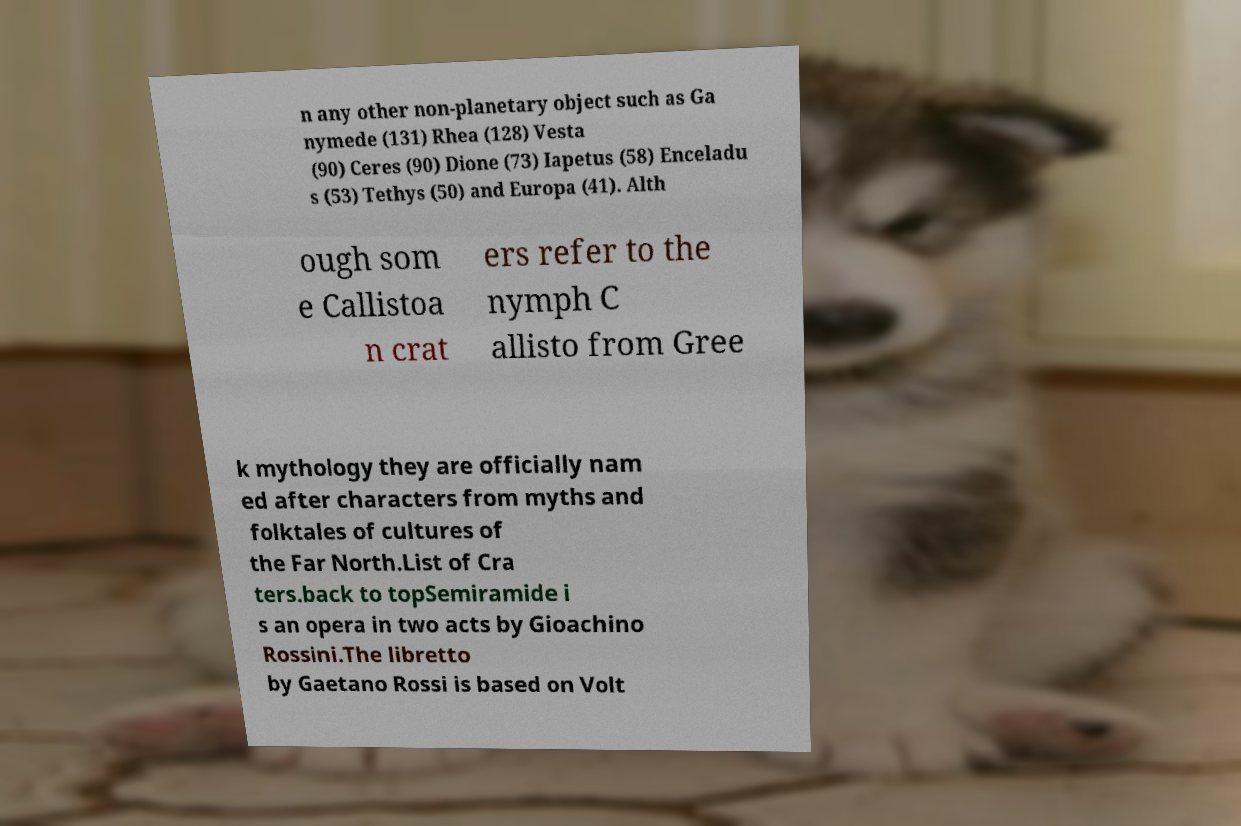I need the written content from this picture converted into text. Can you do that? n any other non-planetary object such as Ga nymede (131) Rhea (128) Vesta (90) Ceres (90) Dione (73) Iapetus (58) Enceladu s (53) Tethys (50) and Europa (41). Alth ough som e Callistoa n crat ers refer to the nymph C allisto from Gree k mythology they are officially nam ed after characters from myths and folktales of cultures of the Far North.List of Cra ters.back to topSemiramide i s an opera in two acts by Gioachino Rossini.The libretto by Gaetano Rossi is based on Volt 